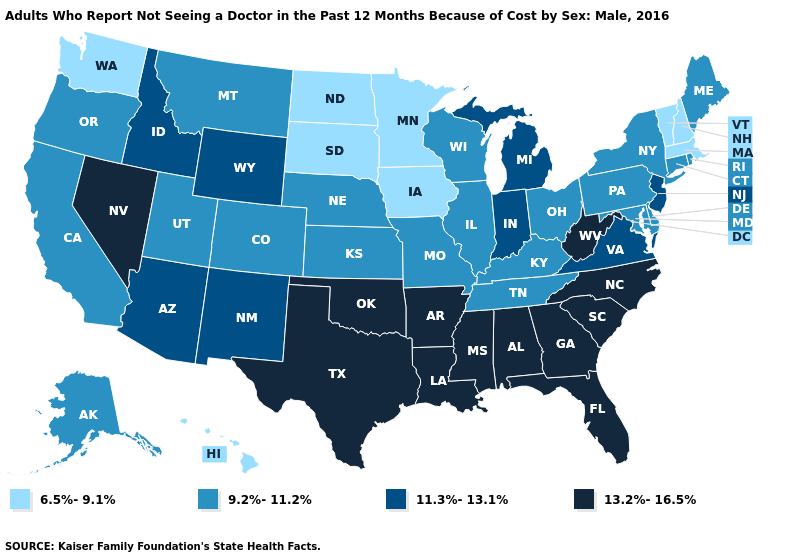What is the highest value in states that border Mississippi?
Answer briefly. 13.2%-16.5%. Name the states that have a value in the range 9.2%-11.2%?
Write a very short answer. Alaska, California, Colorado, Connecticut, Delaware, Illinois, Kansas, Kentucky, Maine, Maryland, Missouri, Montana, Nebraska, New York, Ohio, Oregon, Pennsylvania, Rhode Island, Tennessee, Utah, Wisconsin. What is the value of Louisiana?
Write a very short answer. 13.2%-16.5%. Does the first symbol in the legend represent the smallest category?
Keep it brief. Yes. Does Montana have the highest value in the USA?
Quick response, please. No. What is the value of Nebraska?
Write a very short answer. 9.2%-11.2%. What is the value of Hawaii?
Answer briefly. 6.5%-9.1%. Name the states that have a value in the range 13.2%-16.5%?
Concise answer only. Alabama, Arkansas, Florida, Georgia, Louisiana, Mississippi, Nevada, North Carolina, Oklahoma, South Carolina, Texas, West Virginia. Which states have the highest value in the USA?
Concise answer only. Alabama, Arkansas, Florida, Georgia, Louisiana, Mississippi, Nevada, North Carolina, Oklahoma, South Carolina, Texas, West Virginia. Among the states that border Missouri , does Oklahoma have the highest value?
Be succinct. Yes. Name the states that have a value in the range 9.2%-11.2%?
Quick response, please. Alaska, California, Colorado, Connecticut, Delaware, Illinois, Kansas, Kentucky, Maine, Maryland, Missouri, Montana, Nebraska, New York, Ohio, Oregon, Pennsylvania, Rhode Island, Tennessee, Utah, Wisconsin. Does Iowa have a lower value than Wyoming?
Quick response, please. Yes. What is the value of Utah?
Quick response, please. 9.2%-11.2%. Which states have the lowest value in the USA?
Quick response, please. Hawaii, Iowa, Massachusetts, Minnesota, New Hampshire, North Dakota, South Dakota, Vermont, Washington. 